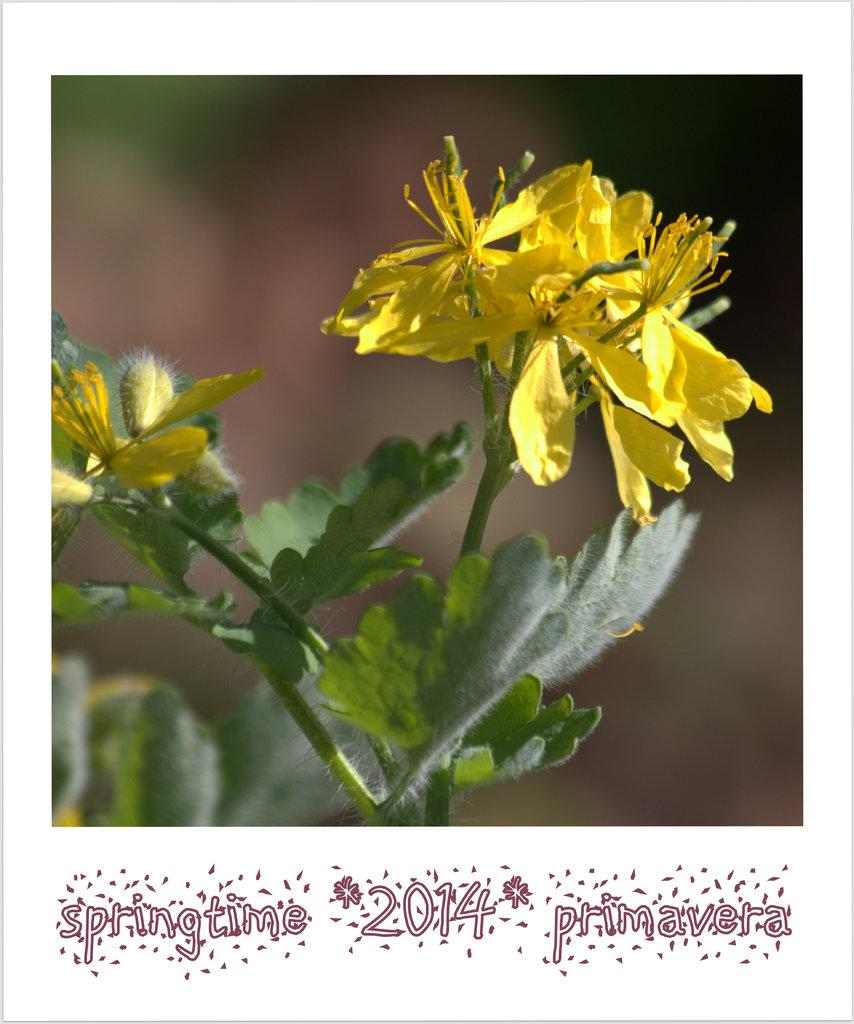What type of flowers can be seen in the image? There are yellow flowers in the image. What color are the leaves associated with the flowers? There are green leaves in the image. How would you describe the background of the image? The background of the image is blurred. Is there any text or logo visible in the image? Yes, there is a watermark at the bottom of the image. What type of milk is being poured over the horse in the image? There is no horse or milk present in the image; it features yellow flowers and green leaves. What genre of literature is being written in the image? There is no writing or prose present in the image; it features yellow flowers and green leaves. 